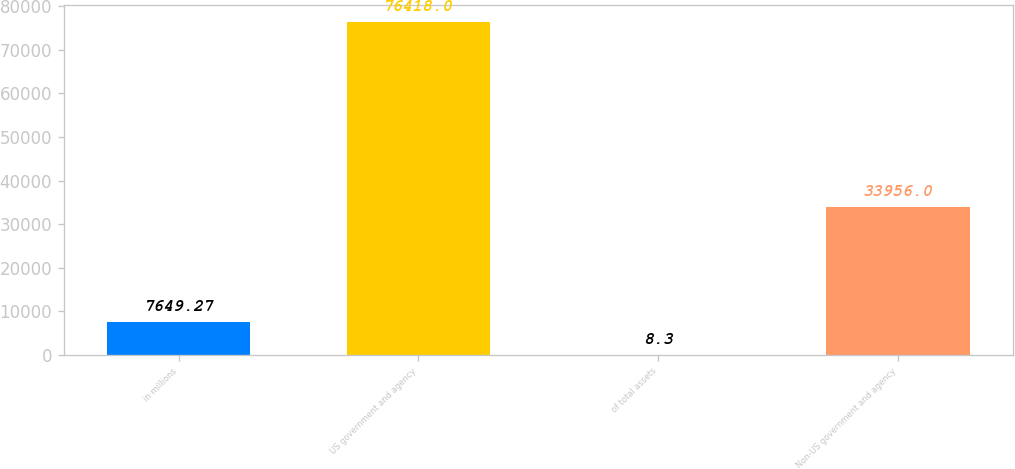Convert chart to OTSL. <chart><loc_0><loc_0><loc_500><loc_500><bar_chart><fcel>in millions<fcel>US government and agency<fcel>of total assets<fcel>Non-US government and agency<nl><fcel>7649.27<fcel>76418<fcel>8.3<fcel>33956<nl></chart> 